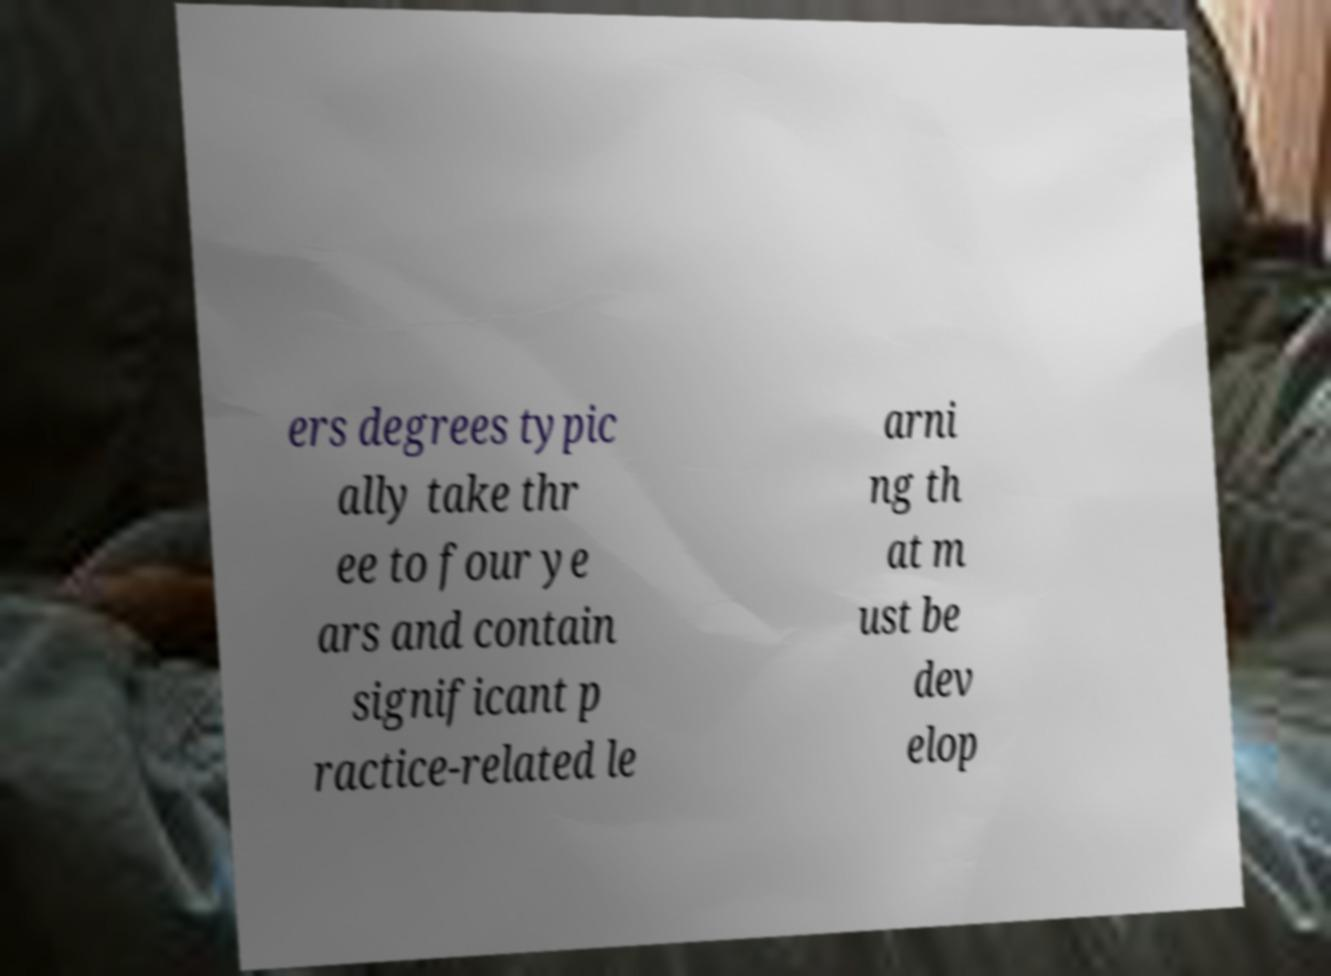I need the written content from this picture converted into text. Can you do that? ers degrees typic ally take thr ee to four ye ars and contain significant p ractice-related le arni ng th at m ust be dev elop 